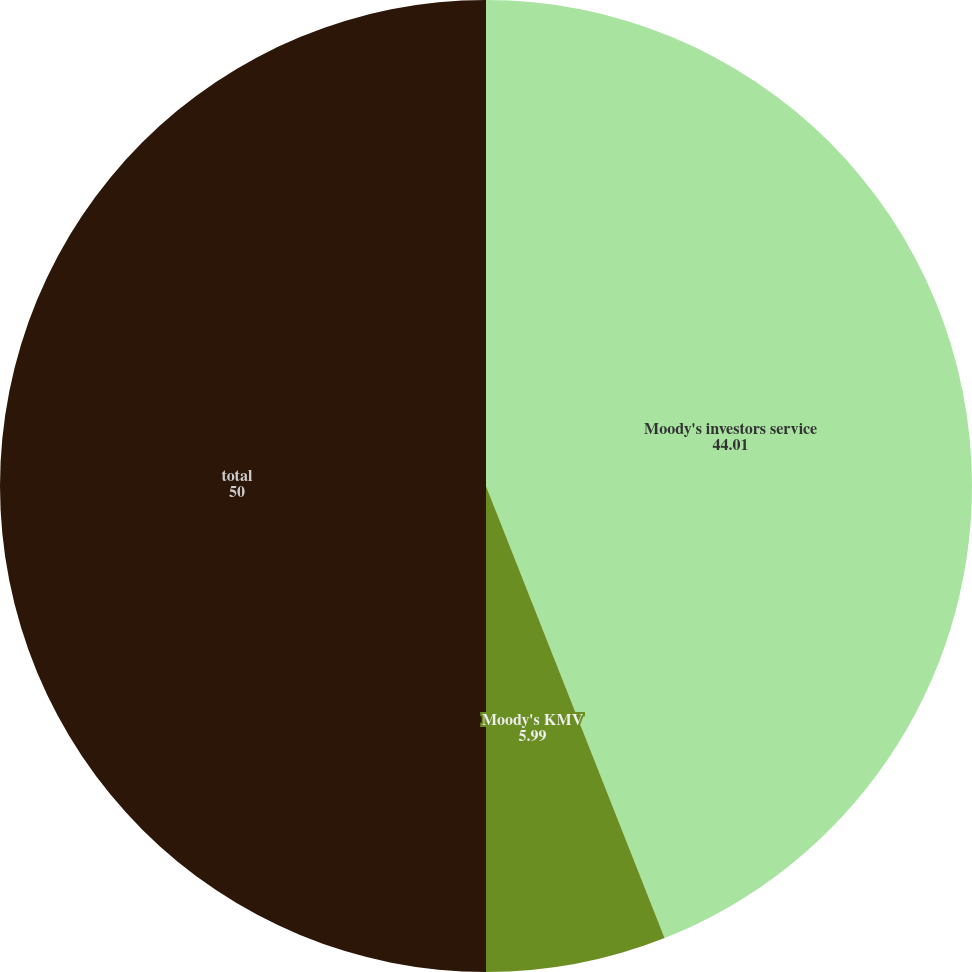Convert chart. <chart><loc_0><loc_0><loc_500><loc_500><pie_chart><fcel>Moody's investors service<fcel>Moody's KMV<fcel>total<nl><fcel>44.01%<fcel>5.99%<fcel>50.0%<nl></chart> 